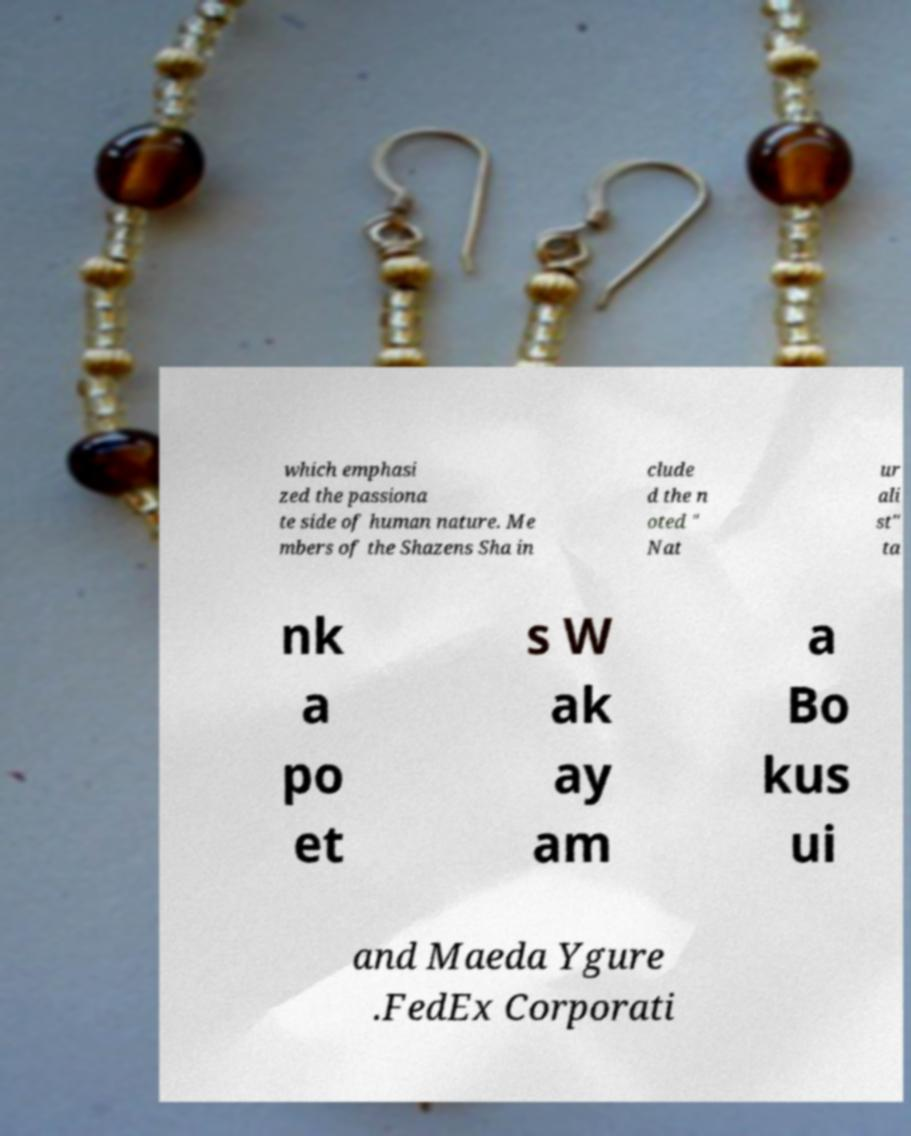Can you accurately transcribe the text from the provided image for me? which emphasi zed the passiona te side of human nature. Me mbers of the Shazens Sha in clude d the n oted " Nat ur ali st" ta nk a po et s W ak ay am a Bo kus ui and Maeda Ygure .FedEx Corporati 